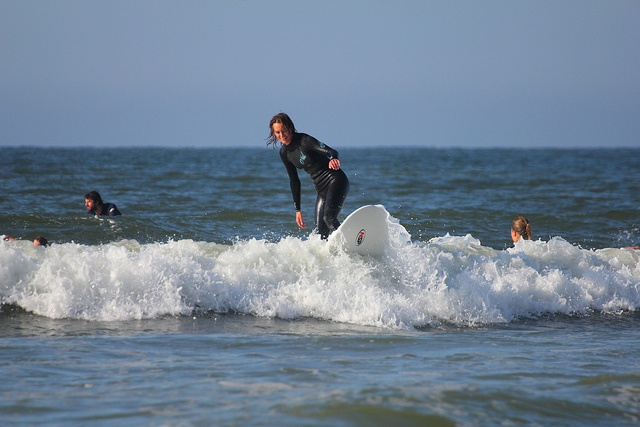Describe the objects in this image and their specific colors. I can see people in gray, black, and maroon tones, surfboard in gray, darkgray, and lightgray tones, people in gray, black, blue, and maroon tones, people in gray, maroon, and black tones, and people in gray, black, and salmon tones in this image. 